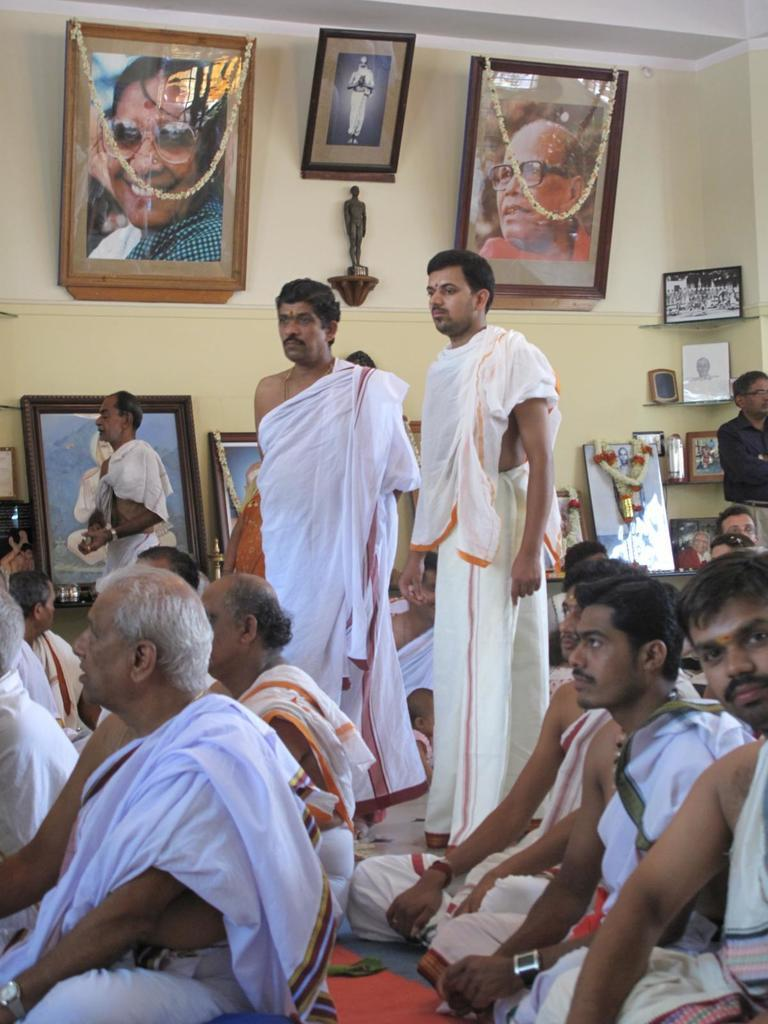What are the people in the image doing? There are people sitting and standing in the image. What can be seen in the background of the image? There is a wall, a statue, garlands, and photo frames in the background of the image. Is there a slope in the image where people can ski? There is no slope or skiing activity present in the image. Can you see a ring on anyone's finger in the image? There is no ring visible on anyone's finger in the image. 